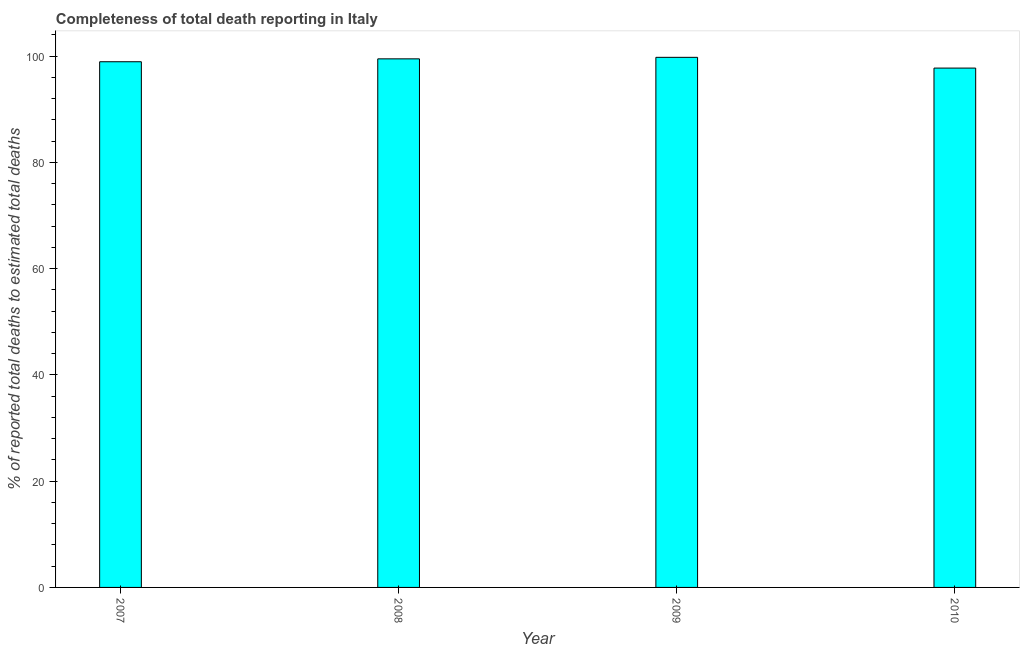Does the graph contain any zero values?
Keep it short and to the point. No. Does the graph contain grids?
Provide a succinct answer. No. What is the title of the graph?
Provide a short and direct response. Completeness of total death reporting in Italy. What is the label or title of the Y-axis?
Your answer should be very brief. % of reported total deaths to estimated total deaths. What is the completeness of total death reports in 2008?
Give a very brief answer. 99.47. Across all years, what is the maximum completeness of total death reports?
Keep it short and to the point. 99.75. Across all years, what is the minimum completeness of total death reports?
Give a very brief answer. 97.73. In which year was the completeness of total death reports minimum?
Provide a succinct answer. 2010. What is the sum of the completeness of total death reports?
Your answer should be very brief. 395.87. What is the difference between the completeness of total death reports in 2009 and 2010?
Your answer should be compact. 2.02. What is the average completeness of total death reports per year?
Your answer should be compact. 98.97. What is the median completeness of total death reports?
Your response must be concise. 99.2. What is the ratio of the completeness of total death reports in 2008 to that in 2009?
Offer a terse response. 1. Is the completeness of total death reports in 2008 less than that in 2009?
Your answer should be compact. Yes. Is the difference between the completeness of total death reports in 2007 and 2009 greater than the difference between any two years?
Offer a very short reply. No. What is the difference between the highest and the second highest completeness of total death reports?
Provide a short and direct response. 0.29. Is the sum of the completeness of total death reports in 2007 and 2008 greater than the maximum completeness of total death reports across all years?
Offer a very short reply. Yes. What is the difference between the highest and the lowest completeness of total death reports?
Your response must be concise. 2.02. Are all the bars in the graph horizontal?
Your answer should be compact. No. How many years are there in the graph?
Provide a short and direct response. 4. What is the difference between two consecutive major ticks on the Y-axis?
Ensure brevity in your answer.  20. Are the values on the major ticks of Y-axis written in scientific E-notation?
Give a very brief answer. No. What is the % of reported total deaths to estimated total deaths of 2007?
Provide a short and direct response. 98.92. What is the % of reported total deaths to estimated total deaths of 2008?
Provide a short and direct response. 99.47. What is the % of reported total deaths to estimated total deaths of 2009?
Offer a very short reply. 99.75. What is the % of reported total deaths to estimated total deaths in 2010?
Provide a succinct answer. 97.73. What is the difference between the % of reported total deaths to estimated total deaths in 2007 and 2008?
Your answer should be compact. -0.54. What is the difference between the % of reported total deaths to estimated total deaths in 2007 and 2009?
Make the answer very short. -0.83. What is the difference between the % of reported total deaths to estimated total deaths in 2007 and 2010?
Your answer should be very brief. 1.19. What is the difference between the % of reported total deaths to estimated total deaths in 2008 and 2009?
Provide a succinct answer. -0.29. What is the difference between the % of reported total deaths to estimated total deaths in 2008 and 2010?
Provide a succinct answer. 1.74. What is the difference between the % of reported total deaths to estimated total deaths in 2009 and 2010?
Provide a short and direct response. 2.02. What is the ratio of the % of reported total deaths to estimated total deaths in 2007 to that in 2010?
Make the answer very short. 1.01. What is the ratio of the % of reported total deaths to estimated total deaths in 2008 to that in 2009?
Your answer should be compact. 1. What is the ratio of the % of reported total deaths to estimated total deaths in 2009 to that in 2010?
Your response must be concise. 1.02. 